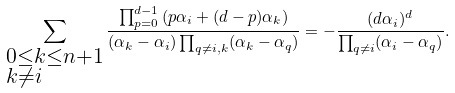Convert formula to latex. <formula><loc_0><loc_0><loc_500><loc_500>\sum _ { \begin{subarray} { c } 0 \leq k \leq n + 1 \\ k \neq i \end{subarray} } \frac { \prod _ { p = 0 } ^ { d - 1 } \left ( p \alpha _ { i } + ( d - p ) \alpha _ { k } \right ) } { ( \alpha _ { k } - \alpha _ { i } ) \prod _ { q \neq i , k } ( \alpha _ { k } - \alpha _ { q } ) } = - \frac { ( d \alpha _ { i } ) ^ { d } } { \prod _ { q \neq i } ( \alpha _ { i } - \alpha _ { q } ) } .</formula> 